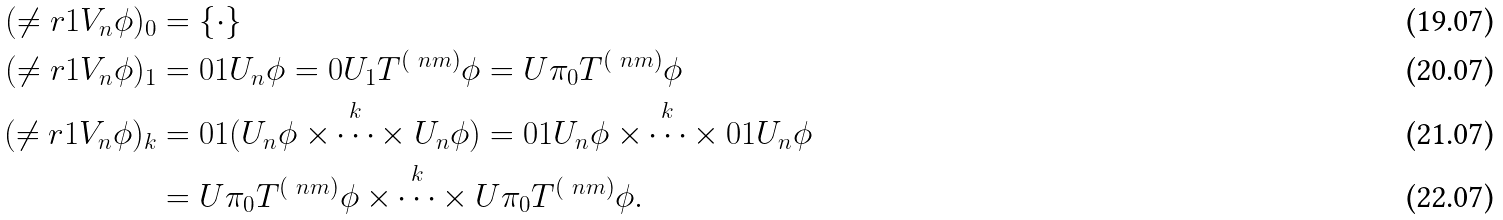<formula> <loc_0><loc_0><loc_500><loc_500>( \ne r { 1 } V _ { n } \phi ) _ { 0 } & = \{ \cdot \} \\ ( \ne r { 1 } V _ { n } \phi ) _ { 1 } & = { 0 } { 1 } U _ { n } \phi = { 0 } U _ { 1 } T ^ { ( \ n m ) } \phi = U \pi _ { 0 } T ^ { ( \ n m ) } \phi \\ ( \ne r { 1 } V _ { n } \phi ) _ { k } & = { 0 } { 1 } ( U _ { n } \phi \overset { k } { \times \dots \times } U _ { n } \phi ) = { 0 } { 1 } U _ { n } \phi \overset { k } { \times \dots \times } { 0 } { 1 } U _ { n } \phi \\ & = U \pi _ { 0 } T ^ { ( \ n m ) } \phi \overset { k } { \times \dots \times } U \pi _ { 0 } T ^ { ( \ n m ) } \phi .</formula> 